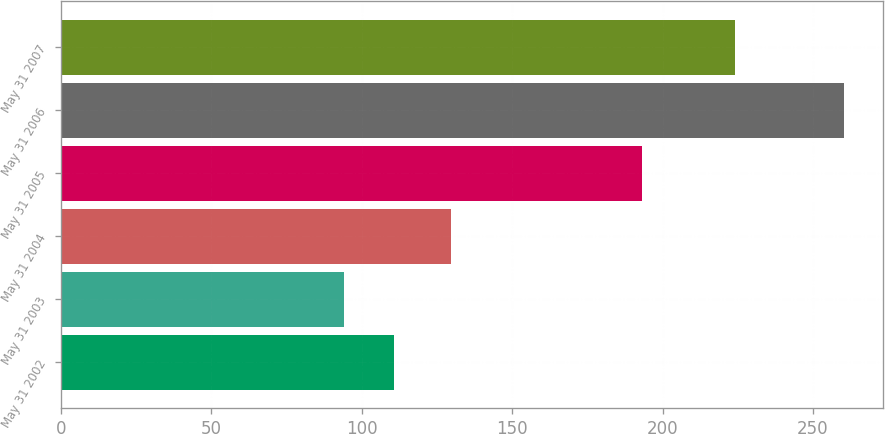Convert chart. <chart><loc_0><loc_0><loc_500><loc_500><bar_chart><fcel>May 31 2002<fcel>May 31 2003<fcel>May 31 2004<fcel>May 31 2005<fcel>May 31 2006<fcel>May 31 2007<nl><fcel>110.82<fcel>94.2<fcel>129.77<fcel>193.3<fcel>260.35<fcel>224.24<nl></chart> 